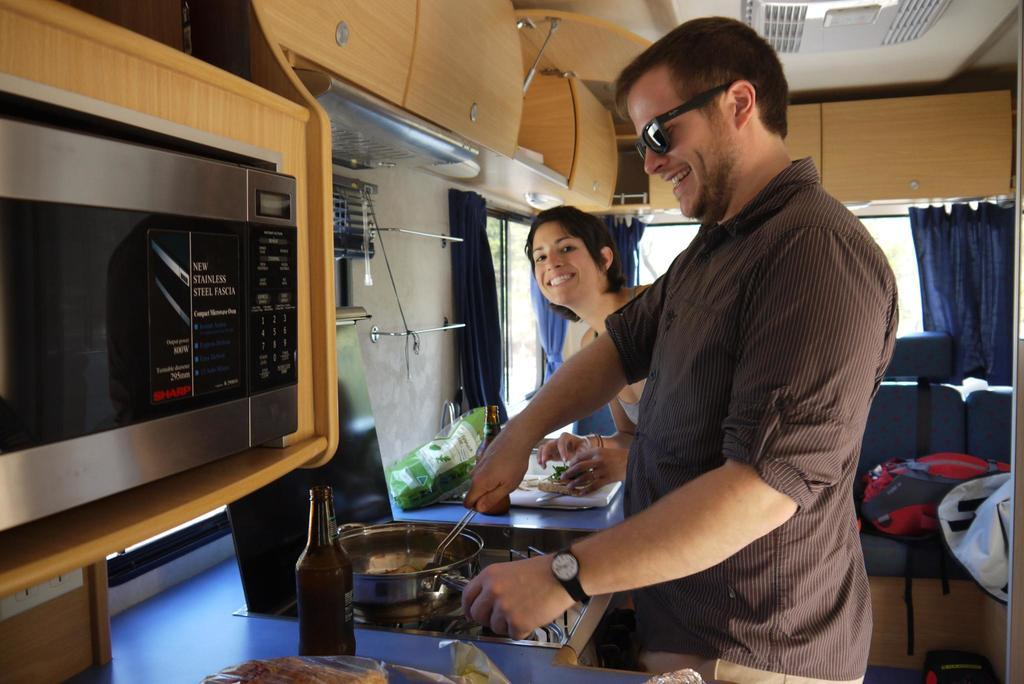<image>
Describe the image concisely. Two people are cooking in an RV kitchen near a microwave with a label that says "Sharp" in red letters. 